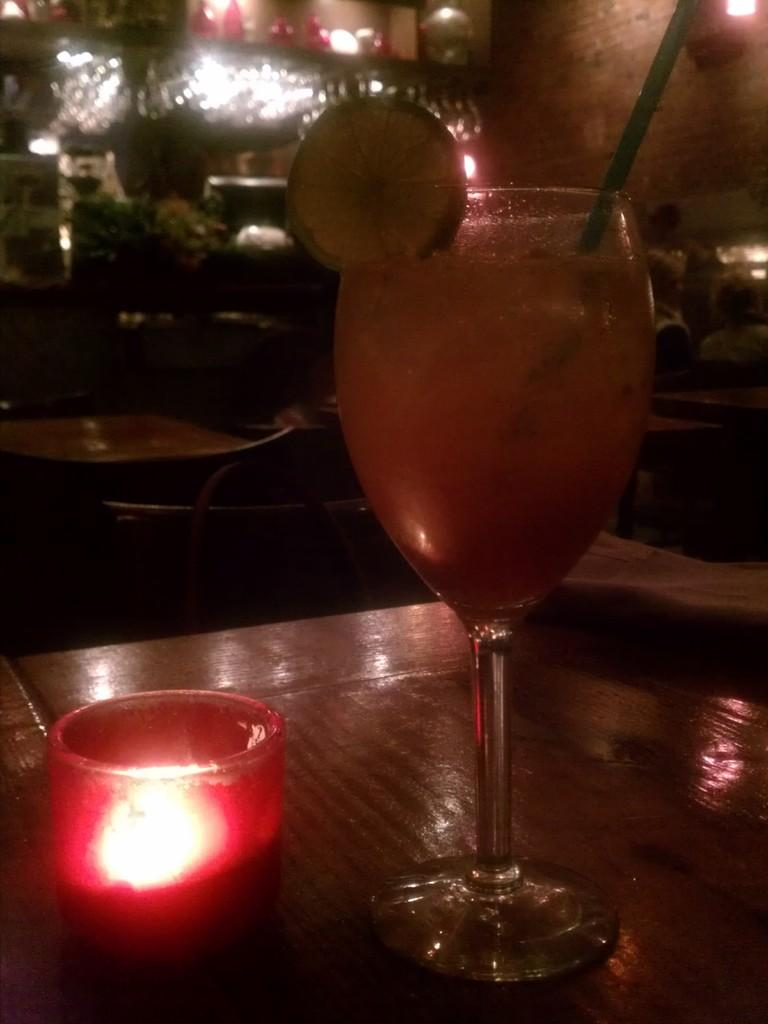What is on the table in the image? There is a glass, a cucumber, and a candle on the table. Are there any other objects on the table? Yes, there are other objects on the table. What can be seen in the background of the image? There are tables, chairs, and lights in the background. What is present on the top right of the image? There is a brick wall on the top right of the image. What type of cabbage is being used to light the candle in the image? There is no cabbage present in the image, and cabbage is not used to light candles. How many quarters can be seen on the table in the image? There are no quarters visible on the table in the image. 